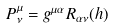Convert formula to latex. <formula><loc_0><loc_0><loc_500><loc_500>P _ { \nu } ^ { \mu } = g ^ { \mu \alpha } R _ { \alpha \nu } ( h )</formula> 